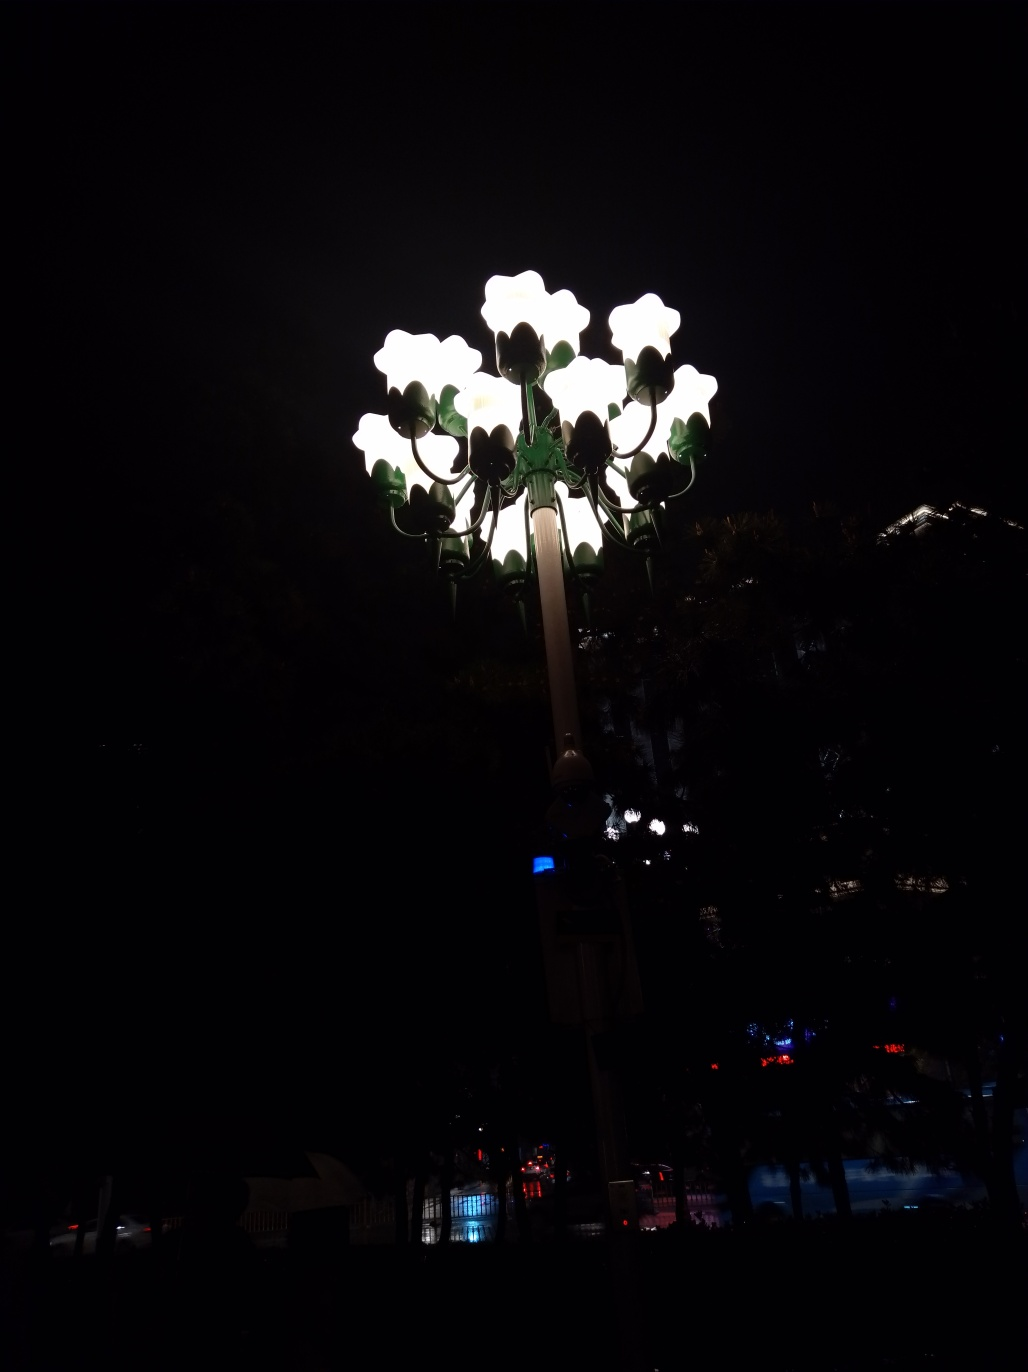What is the quality of this image?
A. Average
B. Good
C. Excellent
D. Poor While the artistic intention might be to focus on the light installation, the photo is underexposed, making it difficult to see the details of the surrounding environment which could contribute to a more comprehensive understanding of the context. The image composition is centered on the lights, which are well captured, but overall, the lack of visibility in the peripheral areas of the photo leads to a quality rating closer to 'D. Poor'. To improve, a balanced exposure capturing both the light from the lamps and the context around them would enhance the image's quality. 